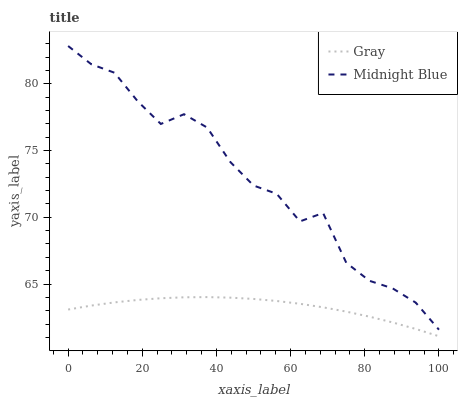Does Midnight Blue have the minimum area under the curve?
Answer yes or no. No. Is Midnight Blue the smoothest?
Answer yes or no. No. Does Midnight Blue have the lowest value?
Answer yes or no. No. Is Gray less than Midnight Blue?
Answer yes or no. Yes. Is Midnight Blue greater than Gray?
Answer yes or no. Yes. Does Gray intersect Midnight Blue?
Answer yes or no. No. 